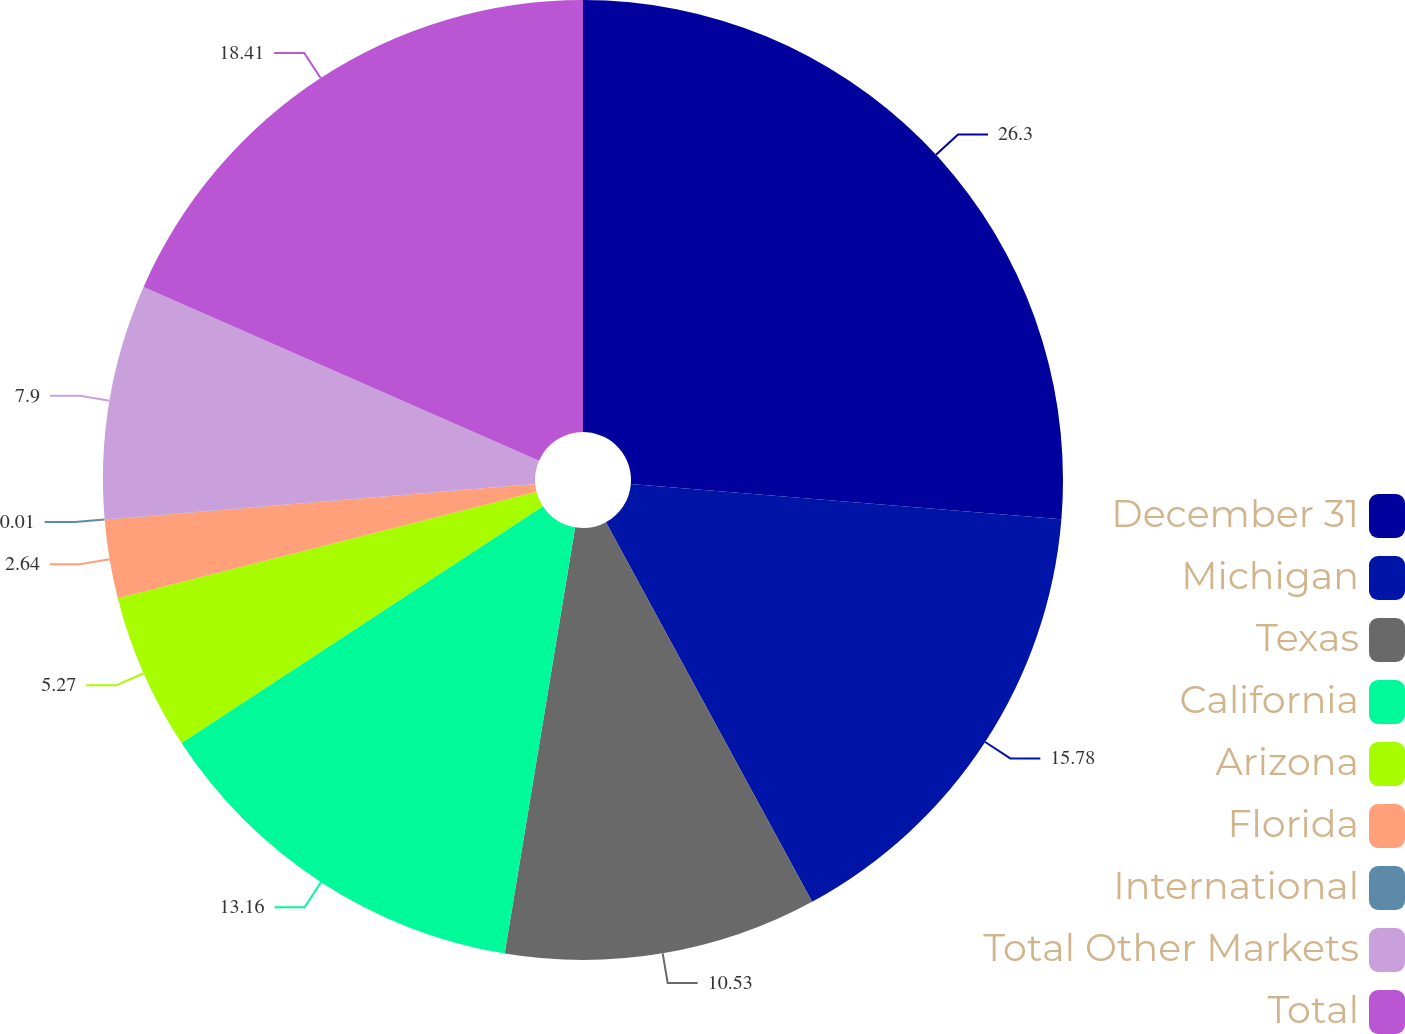Convert chart to OTSL. <chart><loc_0><loc_0><loc_500><loc_500><pie_chart><fcel>December 31<fcel>Michigan<fcel>Texas<fcel>California<fcel>Arizona<fcel>Florida<fcel>International<fcel>Total Other Markets<fcel>Total<nl><fcel>26.3%<fcel>15.78%<fcel>10.53%<fcel>13.16%<fcel>5.27%<fcel>2.64%<fcel>0.01%<fcel>7.9%<fcel>18.41%<nl></chart> 